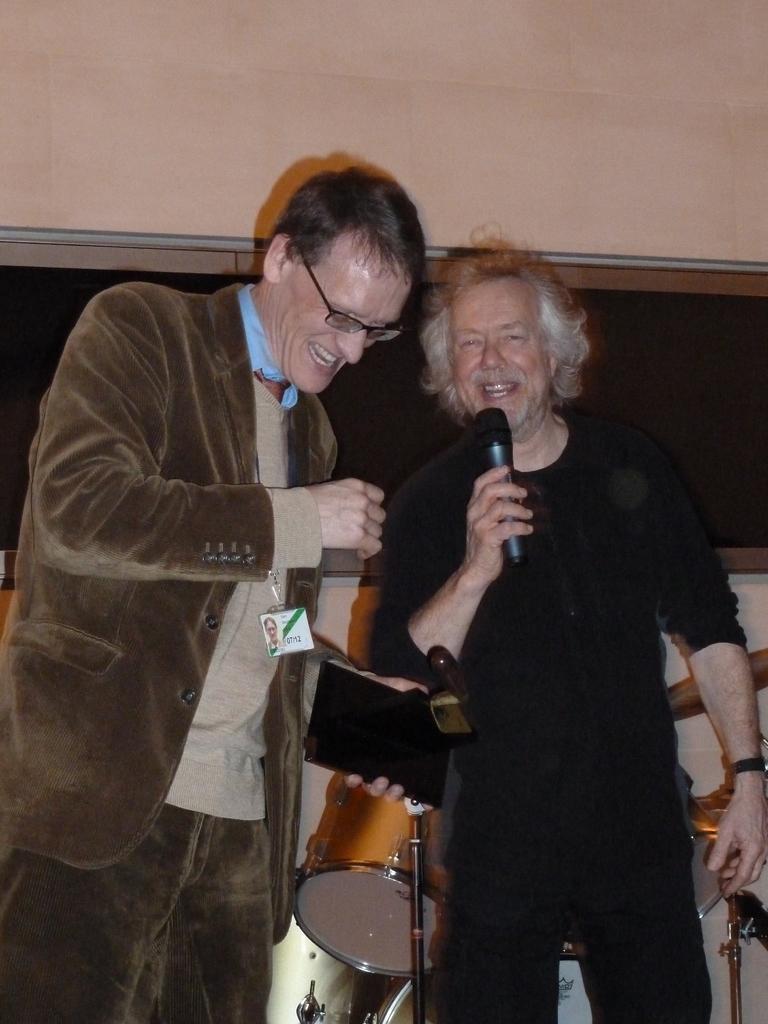Could you give a brief overview of what you see in this image? In the image there are two people standing. The man who is standing to the right side is holding a mic in his hand and the man who is standing beside him is laughing. In the background there is a band. 